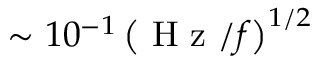Convert formula to latex. <formula><loc_0><loc_0><loc_500><loc_500>\sim 1 0 ^ { - 1 } \left ( H z / f \right ) ^ { 1 / 2 }</formula> 